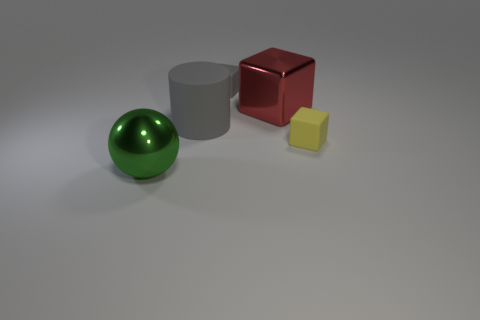Subtract all small cubes. How many cubes are left? 1 Subtract all gray blocks. How many blocks are left? 2 Subtract 2 blocks. How many blocks are left? 1 Subtract all purple cubes. Subtract all gray cylinders. How many cubes are left? 3 Subtract all purple balls. How many yellow cylinders are left? 0 Subtract all large gray rubber cylinders. Subtract all tiny gray blocks. How many objects are left? 3 Add 1 tiny gray cubes. How many tiny gray cubes are left? 2 Add 4 balls. How many balls exist? 5 Add 3 big yellow shiny objects. How many objects exist? 8 Subtract 1 gray cylinders. How many objects are left? 4 